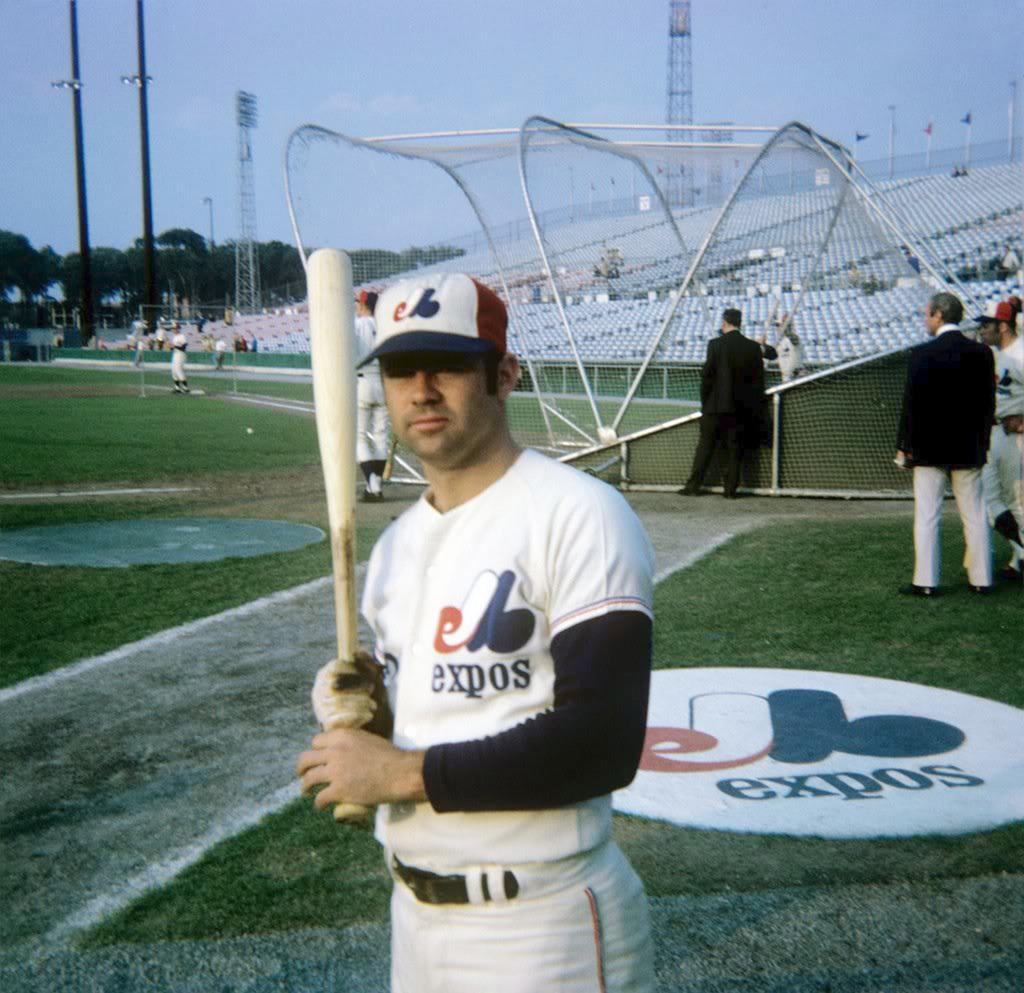<image>
Write a terse but informative summary of the picture. A baseball player for the expos is posing with a baseball bat. 